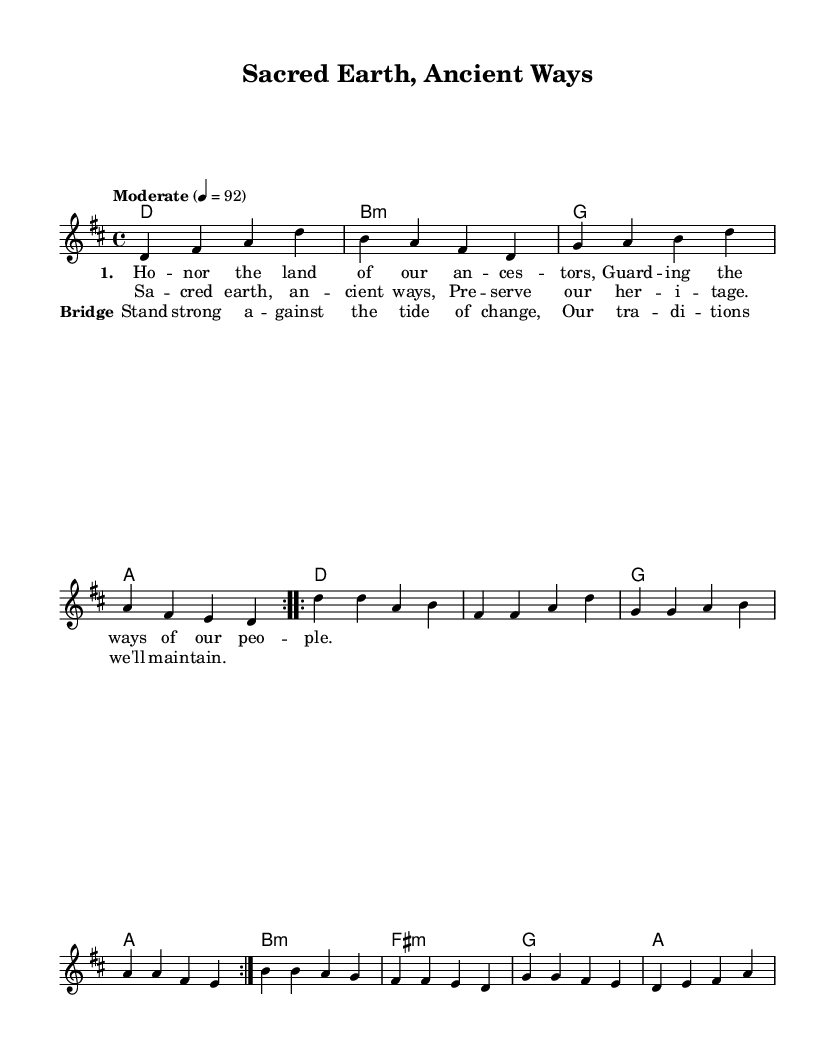What is the key signature of this music? The key signature is indicated at the beginning of the staff. It has two sharps, which correspond to the D major scale.
Answer: D major What is the time signature of this piece? The time signature is shown at the beginning of the score, written as a fraction. It is 4/4, meaning each measure has four beats and a quarter note gets one beat.
Answer: 4/4 What is the tempo marking for the music? The tempo is specified in the score and gives an indication of how fast the music should be played. It is marked as "Moderate" with a metronome marking of 92 beats per minute.
Answer: Moderate 4 = 92 How many verses are present in the sheet music? By analyzing the lyrical sections, we see that there is one verse indicated in the lyrics, so we count that as one verse.
Answer: 1 What are the chord changes for the chorus section? The chord changes for the chorus can be found in the harmonies section just above the chorus lyrics. The chords are G and A for the corresponding lines.
Answer: G, A Which section of the music emphasizes the theme of cultural preservation? The chorus explicitly states "Sacred earth, ancient ways, Preserve our heritage," highlighting the theme of cultural preservation in the lyrics.
Answer: Chorus What is the purpose of the bridge in the song? The bridge serves as a contrasting section that reinforces the main message of the song. It emphasizes standing strong against change and maintaining traditions, thus enhancing the theme of the song.
Answer: Emphasizes traditions 